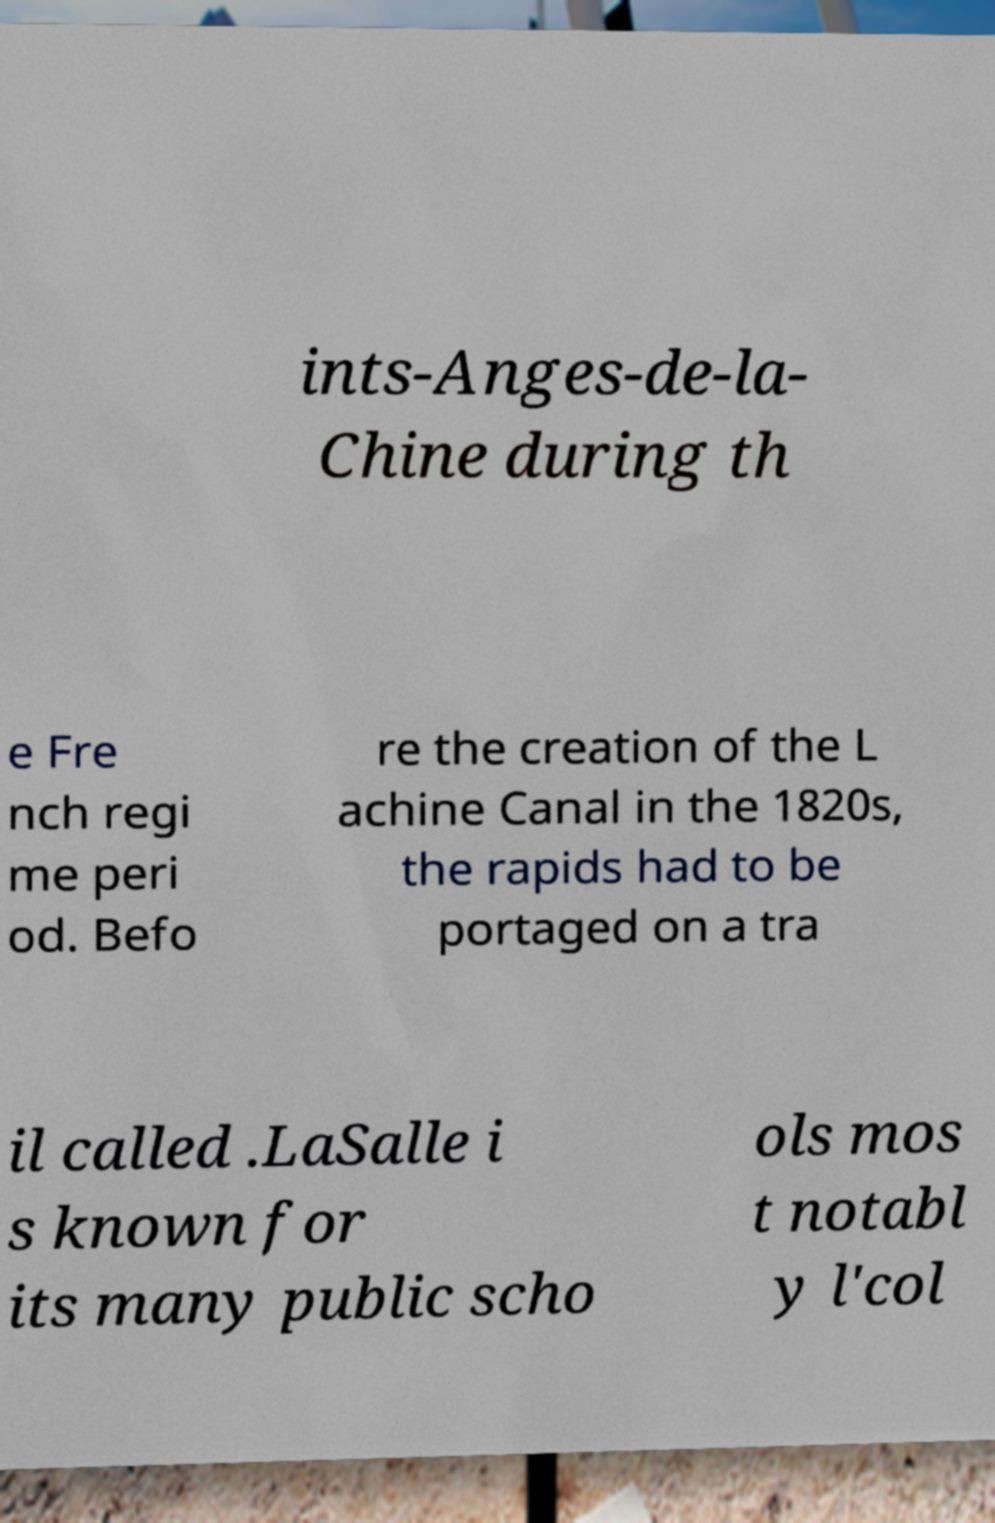I need the written content from this picture converted into text. Can you do that? ints-Anges-de-la- Chine during th e Fre nch regi me peri od. Befo re the creation of the L achine Canal in the 1820s, the rapids had to be portaged on a tra il called .LaSalle i s known for its many public scho ols mos t notabl y l'col 